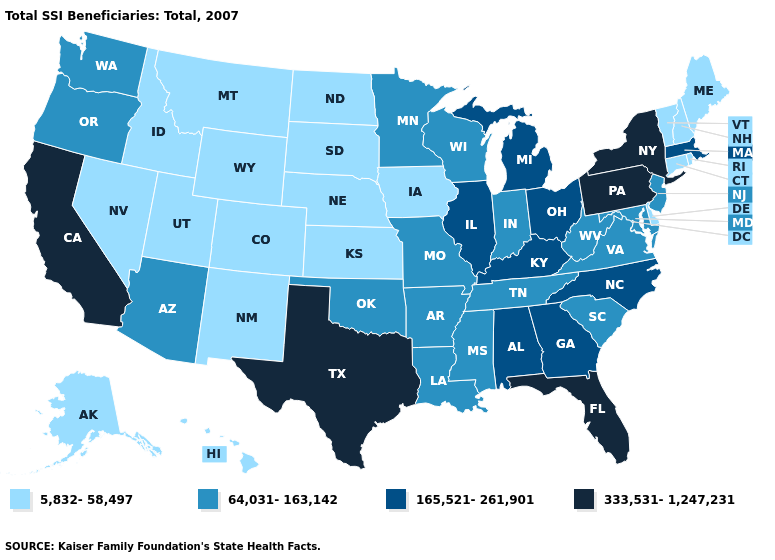What is the highest value in states that border Arizona?
Keep it brief. 333,531-1,247,231. Does New Hampshire have the highest value in the USA?
Short answer required. No. Does Iowa have a higher value than North Carolina?
Write a very short answer. No. What is the value of Nebraska?
Be succinct. 5,832-58,497. Name the states that have a value in the range 64,031-163,142?
Short answer required. Arizona, Arkansas, Indiana, Louisiana, Maryland, Minnesota, Mississippi, Missouri, New Jersey, Oklahoma, Oregon, South Carolina, Tennessee, Virginia, Washington, West Virginia, Wisconsin. Which states hav the highest value in the Northeast?
Answer briefly. New York, Pennsylvania. Among the states that border North Dakota , which have the highest value?
Answer briefly. Minnesota. What is the value of South Carolina?
Be succinct. 64,031-163,142. Is the legend a continuous bar?
Write a very short answer. No. Name the states that have a value in the range 333,531-1,247,231?
Short answer required. California, Florida, New York, Pennsylvania, Texas. What is the lowest value in the USA?
Answer briefly. 5,832-58,497. Name the states that have a value in the range 5,832-58,497?
Concise answer only. Alaska, Colorado, Connecticut, Delaware, Hawaii, Idaho, Iowa, Kansas, Maine, Montana, Nebraska, Nevada, New Hampshire, New Mexico, North Dakota, Rhode Island, South Dakota, Utah, Vermont, Wyoming. Which states have the highest value in the USA?
Short answer required. California, Florida, New York, Pennsylvania, Texas. Among the states that border Pennsylvania , which have the lowest value?
Write a very short answer. Delaware. Does Missouri have the lowest value in the MidWest?
Concise answer only. No. 